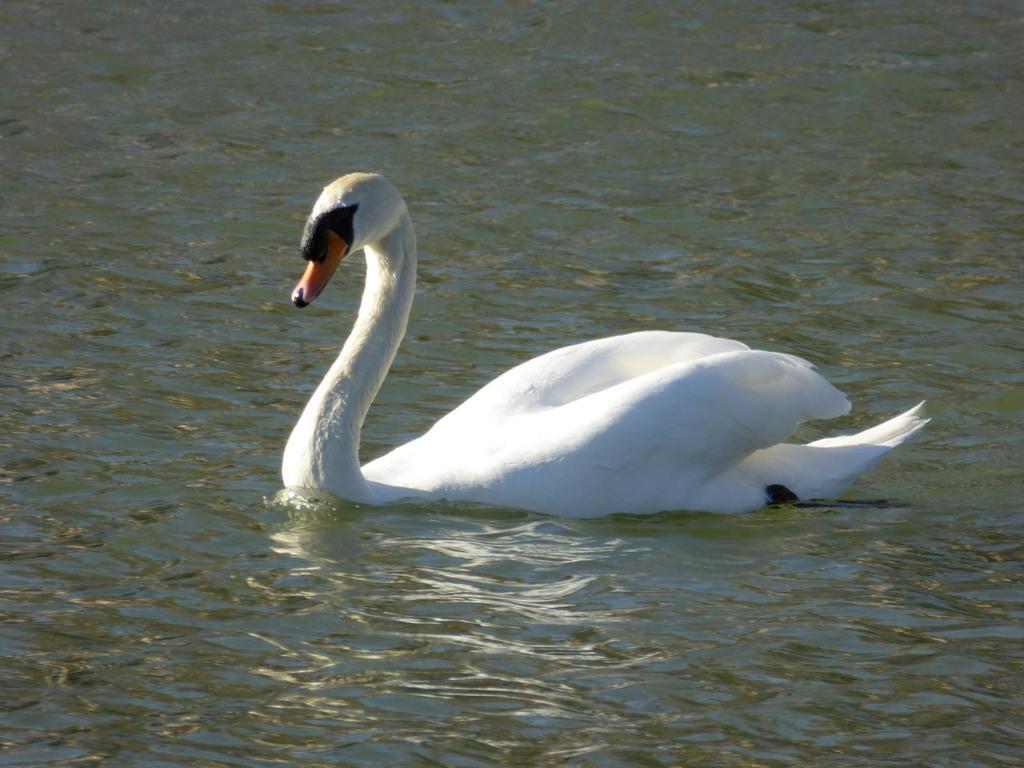In one or two sentences, can you explain what this image depicts? In this picture there is a big white color duck swimming in the lake water. 